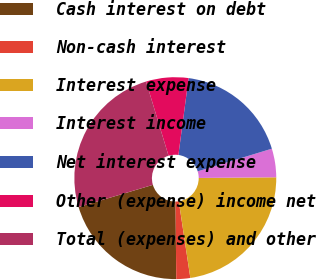<chart> <loc_0><loc_0><loc_500><loc_500><pie_chart><fcel>Cash interest on debt<fcel>Non-cash interest<fcel>Interest expense<fcel>Interest income<fcel>Net interest expense<fcel>Other (expense) income net<fcel>Total (expenses) and other<nl><fcel>20.53%<fcel>2.23%<fcel>22.76%<fcel>4.58%<fcel>18.18%<fcel>6.78%<fcel>24.95%<nl></chart> 